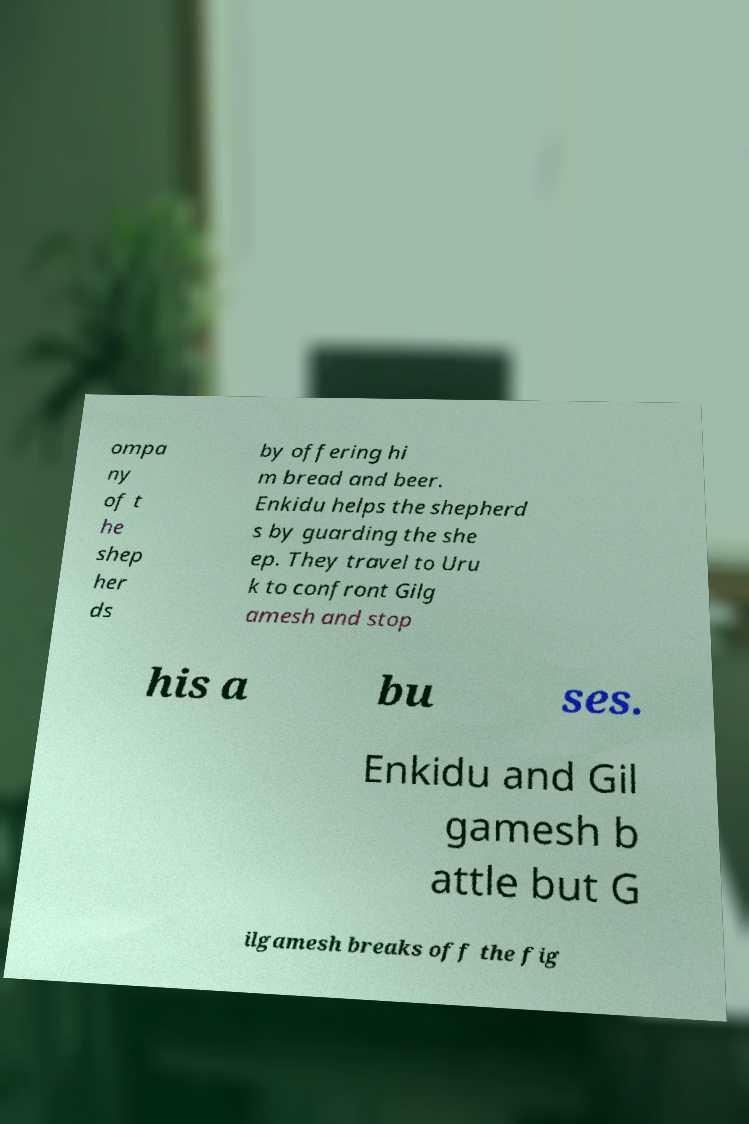Could you assist in decoding the text presented in this image and type it out clearly? ompa ny of t he shep her ds by offering hi m bread and beer. Enkidu helps the shepherd s by guarding the she ep. They travel to Uru k to confront Gilg amesh and stop his a bu ses. Enkidu and Gil gamesh b attle but G ilgamesh breaks off the fig 